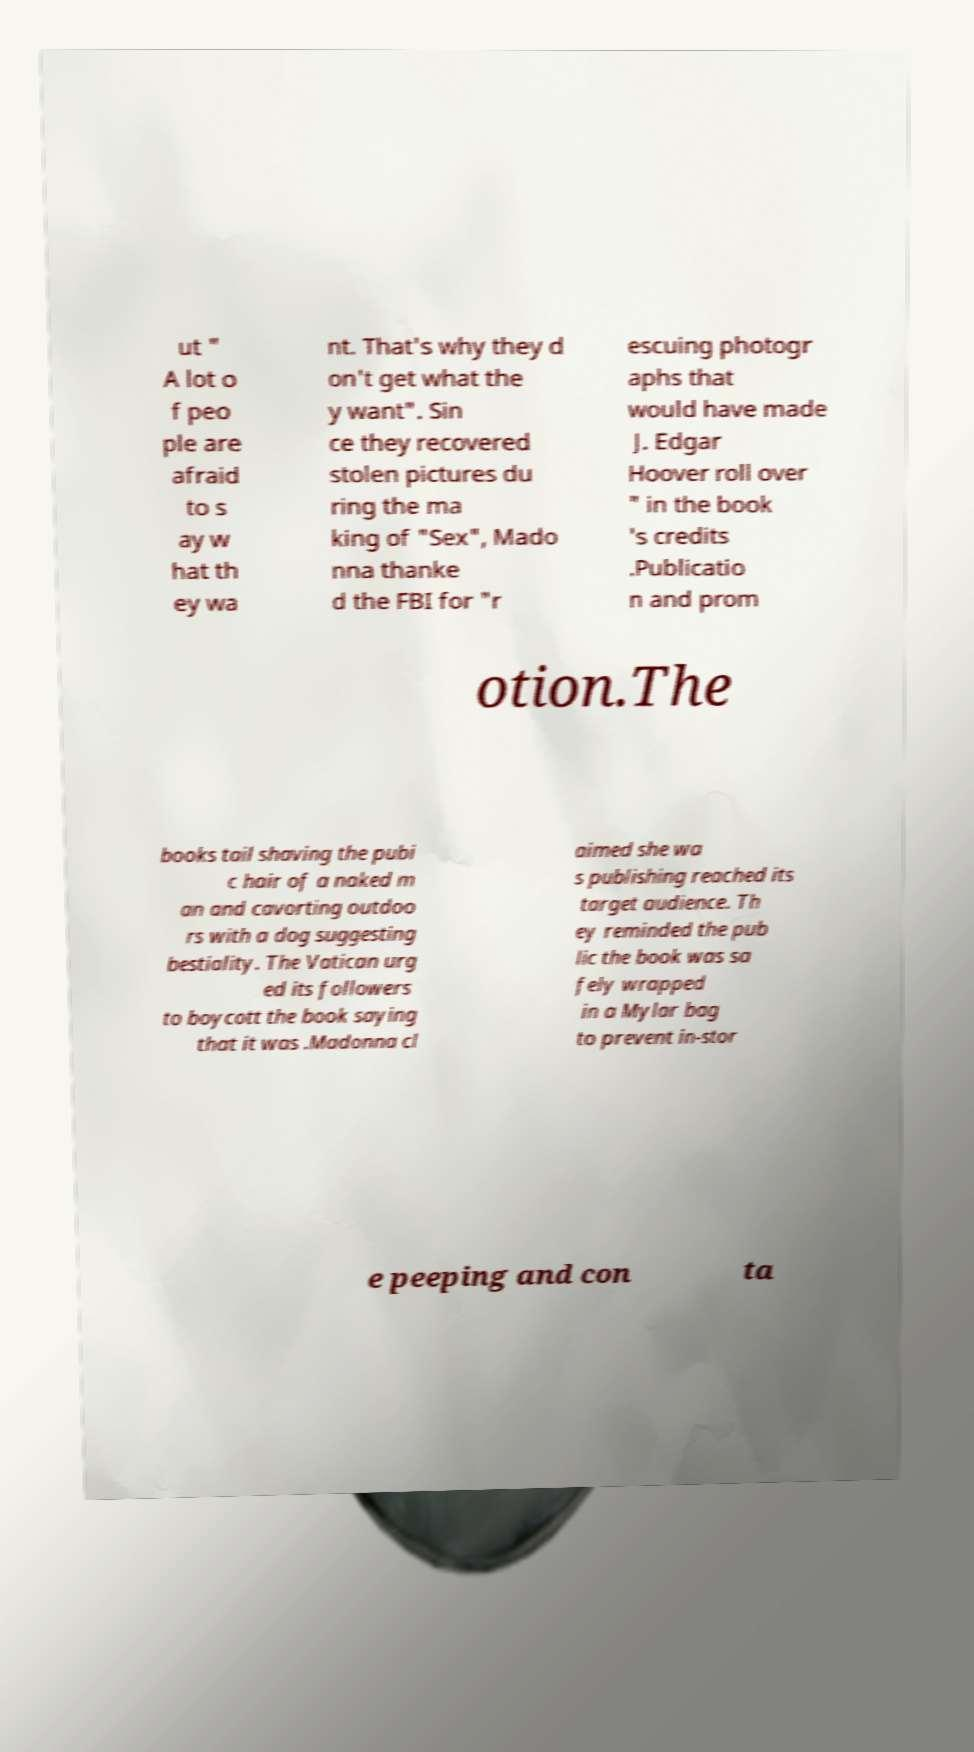Please identify and transcribe the text found in this image. ut " A lot o f peo ple are afraid to s ay w hat th ey wa nt. That's why they d on't get what the y want". Sin ce they recovered stolen pictures du ring the ma king of "Sex", Mado nna thanke d the FBI for "r escuing photogr aphs that would have made J. Edgar Hoover roll over " in the book 's credits .Publicatio n and prom otion.The books tail shaving the pubi c hair of a naked m an and cavorting outdoo rs with a dog suggesting bestiality. The Vatican urg ed its followers to boycott the book saying that it was .Madonna cl aimed she wa s publishing reached its target audience. Th ey reminded the pub lic the book was sa fely wrapped in a Mylar bag to prevent in-stor e peeping and con ta 